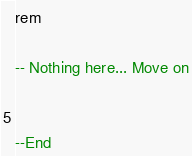Convert code to text. <code><loc_0><loc_0><loc_500><loc_500><_SQL_>rem

-- Nothing here... Move on


--End</code> 